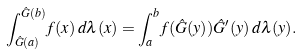<formula> <loc_0><loc_0><loc_500><loc_500>\int _ { \hat { G } ( a ) } ^ { \hat { G } ( b ) } f ( x ) \, d \lambda ( x ) = \int _ { a } ^ { b } f ( \hat { G } ( y ) ) \hat { G } ^ { \prime } ( y ) \, d \lambda ( y ) .</formula> 